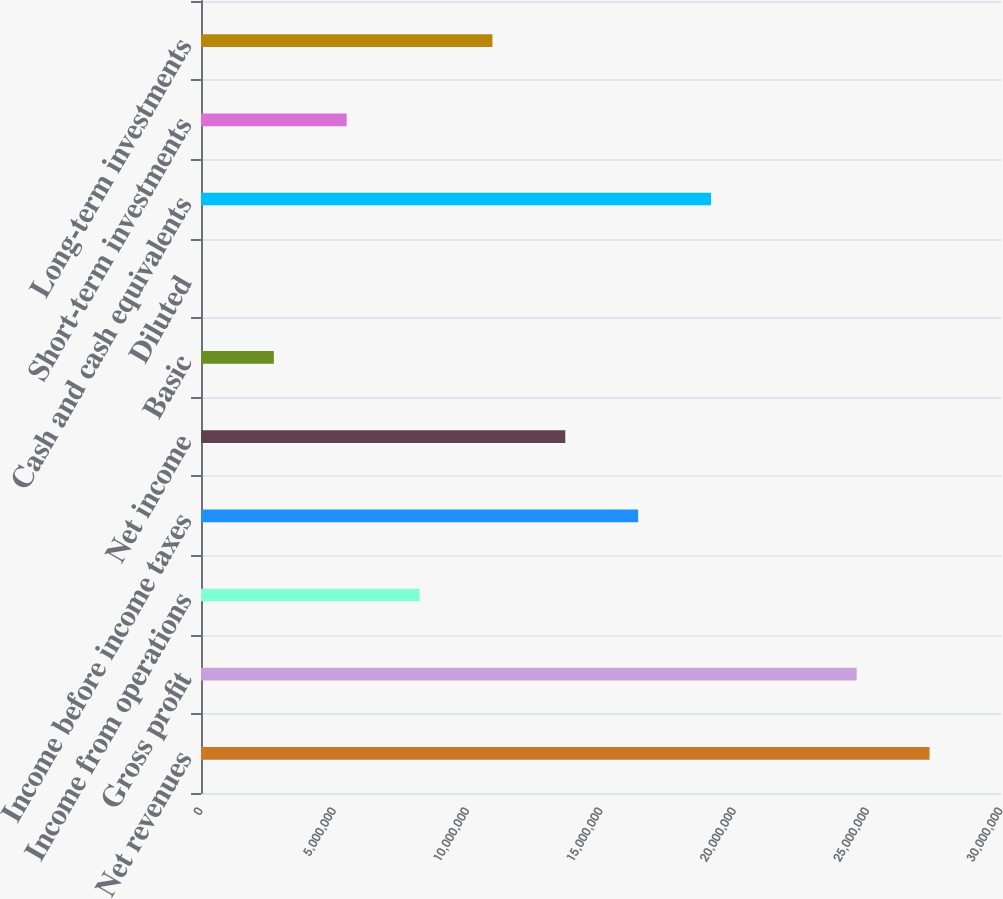<chart> <loc_0><loc_0><loc_500><loc_500><bar_chart><fcel>Net revenues<fcel>Gross profit<fcel>Income from operations<fcel>Income before income taxes<fcel>Net income<fcel>Basic<fcel>Diluted<fcel>Cash and cash equivalents<fcel>Short-term investments<fcel>Long-term investments<nl><fcel>2.73202e+07<fcel>2.45882e+07<fcel>8.19607e+06<fcel>1.63921e+07<fcel>1.36601e+07<fcel>2.73202e+06<fcel>2.46<fcel>1.91242e+07<fcel>5.46405e+06<fcel>1.09281e+07<nl></chart> 